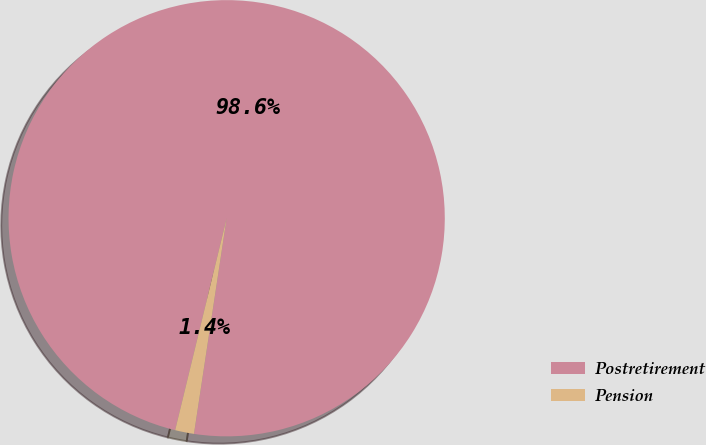<chart> <loc_0><loc_0><loc_500><loc_500><pie_chart><fcel>Postretirement<fcel>Pension<nl><fcel>98.6%<fcel>1.4%<nl></chart> 